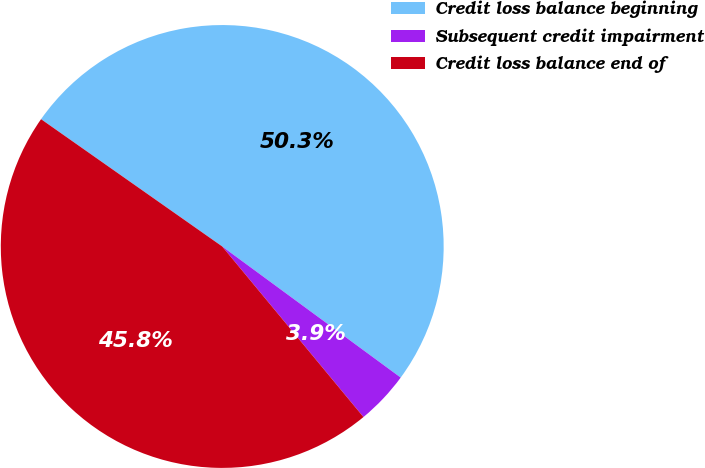Convert chart to OTSL. <chart><loc_0><loc_0><loc_500><loc_500><pie_chart><fcel>Credit loss balance beginning<fcel>Subsequent credit impairment<fcel>Credit loss balance end of<nl><fcel>50.34%<fcel>3.91%<fcel>45.76%<nl></chart> 